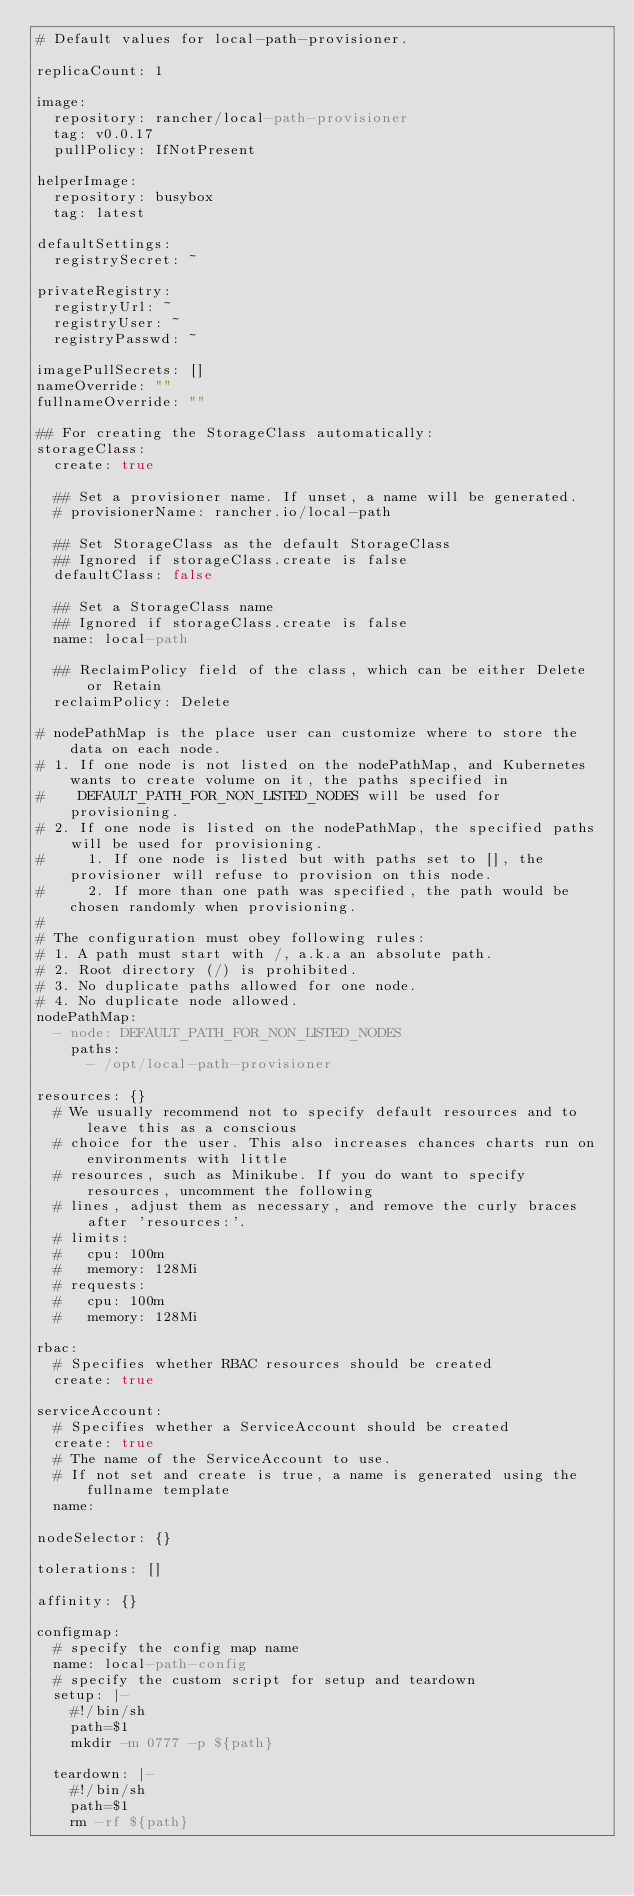Convert code to text. <code><loc_0><loc_0><loc_500><loc_500><_YAML_># Default values for local-path-provisioner.

replicaCount: 1

image:
  repository: rancher/local-path-provisioner
  tag: v0.0.17
  pullPolicy: IfNotPresent

helperImage:
  repository: busybox
  tag: latest

defaultSettings:
  registrySecret: ~

privateRegistry:
  registryUrl: ~
  registryUser: ~
  registryPasswd: ~

imagePullSecrets: []
nameOverride: ""
fullnameOverride: ""

## For creating the StorageClass automatically:
storageClass:
  create: true

  ## Set a provisioner name. If unset, a name will be generated.
  # provisionerName: rancher.io/local-path

  ## Set StorageClass as the default StorageClass
  ## Ignored if storageClass.create is false
  defaultClass: false

  ## Set a StorageClass name
  ## Ignored if storageClass.create is false
  name: local-path

  ## ReclaimPolicy field of the class, which can be either Delete or Retain
  reclaimPolicy: Delete

# nodePathMap is the place user can customize where to store the data on each node.
# 1. If one node is not listed on the nodePathMap, and Kubernetes wants to create volume on it, the paths specified in
#    DEFAULT_PATH_FOR_NON_LISTED_NODES will be used for provisioning.
# 2. If one node is listed on the nodePathMap, the specified paths will be used for provisioning.
#     1. If one node is listed but with paths set to [], the provisioner will refuse to provision on this node.
#     2. If more than one path was specified, the path would be chosen randomly when provisioning.
#
# The configuration must obey following rules:
# 1. A path must start with /, a.k.a an absolute path.
# 2. Root directory (/) is prohibited.
# 3. No duplicate paths allowed for one node.
# 4. No duplicate node allowed.
nodePathMap:
  - node: DEFAULT_PATH_FOR_NON_LISTED_NODES
    paths:
      - /opt/local-path-provisioner

resources: {}
  # We usually recommend not to specify default resources and to leave this as a conscious
  # choice for the user. This also increases chances charts run on environments with little
  # resources, such as Minikube. If you do want to specify resources, uncomment the following
  # lines, adjust them as necessary, and remove the curly braces after 'resources:'.
  # limits:
  #   cpu: 100m
  #   memory: 128Mi
  # requests:
  #   cpu: 100m
  #   memory: 128Mi

rbac:
  # Specifies whether RBAC resources should be created
  create: true

serviceAccount:
  # Specifies whether a ServiceAccount should be created
  create: true
  # The name of the ServiceAccount to use.
  # If not set and create is true, a name is generated using the fullname template
  name:

nodeSelector: {}

tolerations: []

affinity: {}

configmap:
  # specify the config map name
  name: local-path-config
  # specify the custom script for setup and teardown
  setup: |-
    #!/bin/sh
    path=$1
    mkdir -m 0777 -p ${path}

  teardown: |-
    #!/bin/sh
    path=$1
    rm -rf ${path}

</code> 